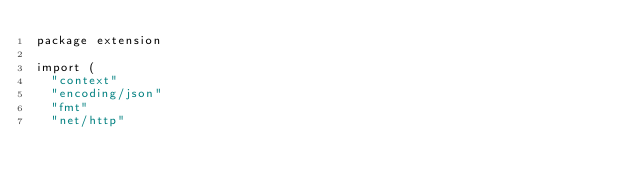Convert code to text. <code><loc_0><loc_0><loc_500><loc_500><_Go_>package extension

import (
	"context"
	"encoding/json"
	"fmt"
	"net/http"</code> 